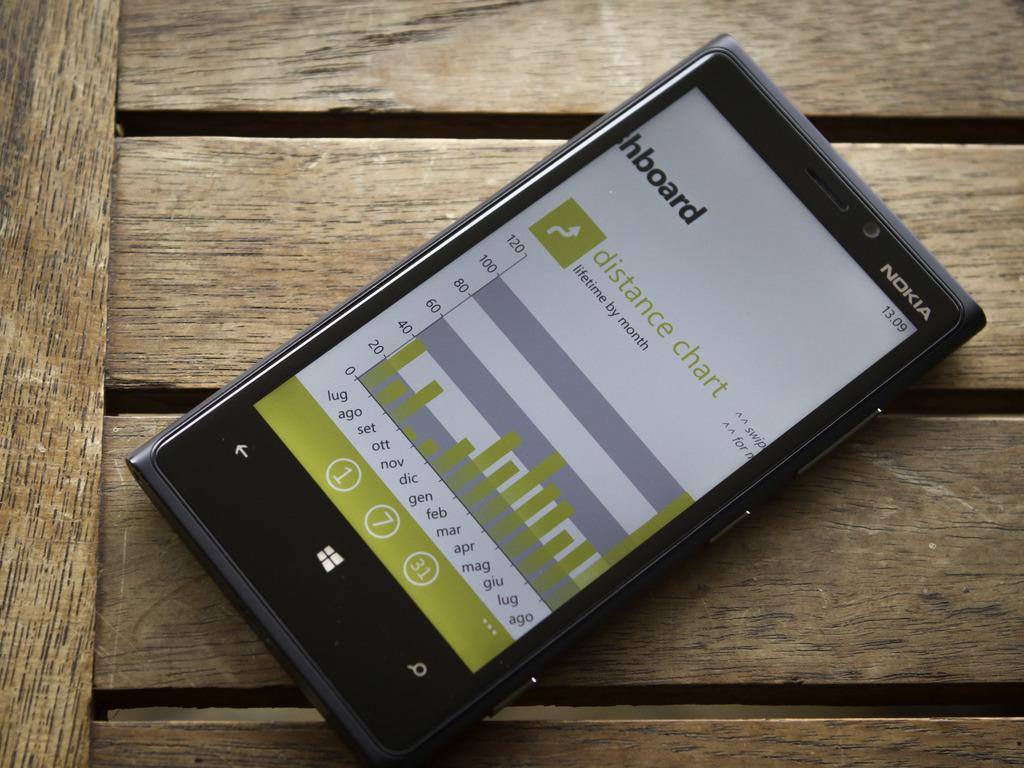Provide a one-sentence caption for the provided image. A Nokia brand phone displays a distance chart. 